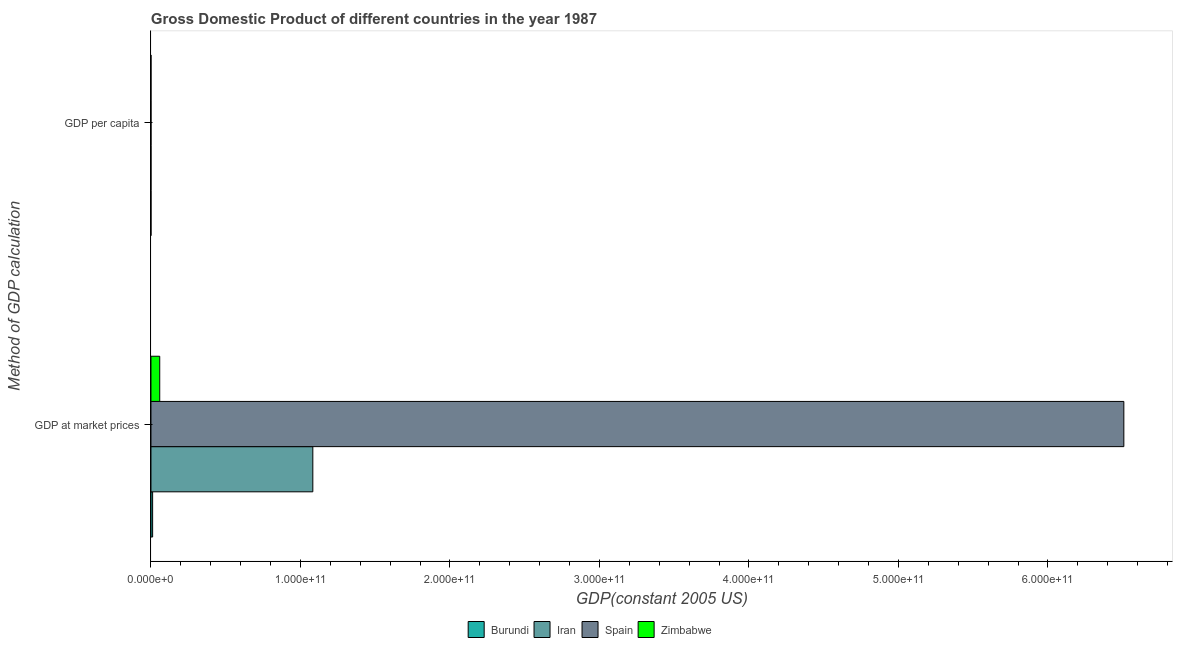How many groups of bars are there?
Offer a terse response. 2. Are the number of bars on each tick of the Y-axis equal?
Your answer should be compact. Yes. What is the label of the 1st group of bars from the top?
Your answer should be very brief. GDP per capita. What is the gdp per capita in Iran?
Your answer should be very brief. 2116.74. Across all countries, what is the maximum gdp per capita?
Your response must be concise. 1.68e+04. Across all countries, what is the minimum gdp at market prices?
Provide a short and direct response. 1.11e+09. In which country was the gdp per capita maximum?
Your response must be concise. Spain. In which country was the gdp per capita minimum?
Your answer should be very brief. Burundi. What is the total gdp at market prices in the graph?
Ensure brevity in your answer.  7.66e+11. What is the difference between the gdp at market prices in Iran and that in Burundi?
Offer a terse response. 1.07e+11. What is the difference between the gdp per capita in Spain and the gdp at market prices in Zimbabwe?
Make the answer very short. -5.86e+09. What is the average gdp at market prices per country?
Ensure brevity in your answer.  1.92e+11. What is the difference between the gdp per capita and gdp at market prices in Iran?
Offer a terse response. -1.08e+11. In how many countries, is the gdp per capita greater than 200000000000 US$?
Offer a very short reply. 0. What is the ratio of the gdp per capita in Iran to that in Spain?
Make the answer very short. 0.13. What does the 3rd bar from the top in GDP at market prices represents?
Ensure brevity in your answer.  Iran. What does the 3rd bar from the bottom in GDP per capita represents?
Keep it short and to the point. Spain. Are all the bars in the graph horizontal?
Your answer should be very brief. Yes. How many countries are there in the graph?
Make the answer very short. 4. What is the difference between two consecutive major ticks on the X-axis?
Your answer should be very brief. 1.00e+11. Does the graph contain any zero values?
Offer a terse response. No. How many legend labels are there?
Your answer should be very brief. 4. How are the legend labels stacked?
Provide a short and direct response. Horizontal. What is the title of the graph?
Ensure brevity in your answer.  Gross Domestic Product of different countries in the year 1987. Does "Libya" appear as one of the legend labels in the graph?
Your answer should be very brief. No. What is the label or title of the X-axis?
Ensure brevity in your answer.  GDP(constant 2005 US). What is the label or title of the Y-axis?
Ensure brevity in your answer.  Method of GDP calculation. What is the GDP(constant 2005 US) of Burundi in GDP at market prices?
Your answer should be very brief. 1.11e+09. What is the GDP(constant 2005 US) in Iran in GDP at market prices?
Offer a very short reply. 1.08e+11. What is the GDP(constant 2005 US) in Spain in GDP at market prices?
Keep it short and to the point. 6.51e+11. What is the GDP(constant 2005 US) in Zimbabwe in GDP at market prices?
Offer a very short reply. 5.86e+09. What is the GDP(constant 2005 US) of Burundi in GDP per capita?
Make the answer very short. 217.47. What is the GDP(constant 2005 US) in Iran in GDP per capita?
Provide a succinct answer. 2116.74. What is the GDP(constant 2005 US) in Spain in GDP per capita?
Your response must be concise. 1.68e+04. What is the GDP(constant 2005 US) in Zimbabwe in GDP per capita?
Provide a short and direct response. 614.99. Across all Method of GDP calculation, what is the maximum GDP(constant 2005 US) of Burundi?
Your response must be concise. 1.11e+09. Across all Method of GDP calculation, what is the maximum GDP(constant 2005 US) in Iran?
Offer a very short reply. 1.08e+11. Across all Method of GDP calculation, what is the maximum GDP(constant 2005 US) of Spain?
Make the answer very short. 6.51e+11. Across all Method of GDP calculation, what is the maximum GDP(constant 2005 US) of Zimbabwe?
Provide a succinct answer. 5.86e+09. Across all Method of GDP calculation, what is the minimum GDP(constant 2005 US) of Burundi?
Offer a very short reply. 217.47. Across all Method of GDP calculation, what is the minimum GDP(constant 2005 US) in Iran?
Provide a short and direct response. 2116.74. Across all Method of GDP calculation, what is the minimum GDP(constant 2005 US) of Spain?
Provide a short and direct response. 1.68e+04. Across all Method of GDP calculation, what is the minimum GDP(constant 2005 US) of Zimbabwe?
Provide a succinct answer. 614.99. What is the total GDP(constant 2005 US) of Burundi in the graph?
Your answer should be compact. 1.11e+09. What is the total GDP(constant 2005 US) in Iran in the graph?
Your answer should be compact. 1.08e+11. What is the total GDP(constant 2005 US) of Spain in the graph?
Provide a succinct answer. 6.51e+11. What is the total GDP(constant 2005 US) of Zimbabwe in the graph?
Give a very brief answer. 5.86e+09. What is the difference between the GDP(constant 2005 US) in Burundi in GDP at market prices and that in GDP per capita?
Keep it short and to the point. 1.11e+09. What is the difference between the GDP(constant 2005 US) in Iran in GDP at market prices and that in GDP per capita?
Ensure brevity in your answer.  1.08e+11. What is the difference between the GDP(constant 2005 US) of Spain in GDP at market prices and that in GDP per capita?
Your answer should be very brief. 6.51e+11. What is the difference between the GDP(constant 2005 US) of Zimbabwe in GDP at market prices and that in GDP per capita?
Ensure brevity in your answer.  5.86e+09. What is the difference between the GDP(constant 2005 US) of Burundi in GDP at market prices and the GDP(constant 2005 US) of Iran in GDP per capita?
Your response must be concise. 1.11e+09. What is the difference between the GDP(constant 2005 US) of Burundi in GDP at market prices and the GDP(constant 2005 US) of Spain in GDP per capita?
Offer a terse response. 1.11e+09. What is the difference between the GDP(constant 2005 US) in Burundi in GDP at market prices and the GDP(constant 2005 US) in Zimbabwe in GDP per capita?
Your response must be concise. 1.11e+09. What is the difference between the GDP(constant 2005 US) of Iran in GDP at market prices and the GDP(constant 2005 US) of Spain in GDP per capita?
Provide a succinct answer. 1.08e+11. What is the difference between the GDP(constant 2005 US) of Iran in GDP at market prices and the GDP(constant 2005 US) of Zimbabwe in GDP per capita?
Make the answer very short. 1.08e+11. What is the difference between the GDP(constant 2005 US) in Spain in GDP at market prices and the GDP(constant 2005 US) in Zimbabwe in GDP per capita?
Provide a succinct answer. 6.51e+11. What is the average GDP(constant 2005 US) of Burundi per Method of GDP calculation?
Your answer should be very brief. 5.55e+08. What is the average GDP(constant 2005 US) of Iran per Method of GDP calculation?
Your answer should be compact. 5.41e+1. What is the average GDP(constant 2005 US) in Spain per Method of GDP calculation?
Your answer should be compact. 3.25e+11. What is the average GDP(constant 2005 US) of Zimbabwe per Method of GDP calculation?
Offer a terse response. 2.93e+09. What is the difference between the GDP(constant 2005 US) in Burundi and GDP(constant 2005 US) in Iran in GDP at market prices?
Keep it short and to the point. -1.07e+11. What is the difference between the GDP(constant 2005 US) of Burundi and GDP(constant 2005 US) of Spain in GDP at market prices?
Offer a very short reply. -6.50e+11. What is the difference between the GDP(constant 2005 US) of Burundi and GDP(constant 2005 US) of Zimbabwe in GDP at market prices?
Make the answer very short. -4.75e+09. What is the difference between the GDP(constant 2005 US) in Iran and GDP(constant 2005 US) in Spain in GDP at market prices?
Offer a terse response. -5.43e+11. What is the difference between the GDP(constant 2005 US) in Iran and GDP(constant 2005 US) in Zimbabwe in GDP at market prices?
Your response must be concise. 1.02e+11. What is the difference between the GDP(constant 2005 US) of Spain and GDP(constant 2005 US) of Zimbabwe in GDP at market prices?
Make the answer very short. 6.45e+11. What is the difference between the GDP(constant 2005 US) in Burundi and GDP(constant 2005 US) in Iran in GDP per capita?
Provide a succinct answer. -1899.27. What is the difference between the GDP(constant 2005 US) of Burundi and GDP(constant 2005 US) of Spain in GDP per capita?
Ensure brevity in your answer.  -1.66e+04. What is the difference between the GDP(constant 2005 US) of Burundi and GDP(constant 2005 US) of Zimbabwe in GDP per capita?
Provide a short and direct response. -397.52. What is the difference between the GDP(constant 2005 US) in Iran and GDP(constant 2005 US) in Spain in GDP per capita?
Ensure brevity in your answer.  -1.47e+04. What is the difference between the GDP(constant 2005 US) in Iran and GDP(constant 2005 US) in Zimbabwe in GDP per capita?
Your response must be concise. 1501.75. What is the difference between the GDP(constant 2005 US) in Spain and GDP(constant 2005 US) in Zimbabwe in GDP per capita?
Offer a terse response. 1.62e+04. What is the ratio of the GDP(constant 2005 US) of Burundi in GDP at market prices to that in GDP per capita?
Offer a very short reply. 5.11e+06. What is the ratio of the GDP(constant 2005 US) in Iran in GDP at market prices to that in GDP per capita?
Make the answer very short. 5.12e+07. What is the ratio of the GDP(constant 2005 US) of Spain in GDP at market prices to that in GDP per capita?
Offer a terse response. 3.86e+07. What is the ratio of the GDP(constant 2005 US) in Zimbabwe in GDP at market prices to that in GDP per capita?
Provide a succinct answer. 9.54e+06. What is the difference between the highest and the second highest GDP(constant 2005 US) of Burundi?
Give a very brief answer. 1.11e+09. What is the difference between the highest and the second highest GDP(constant 2005 US) of Iran?
Provide a succinct answer. 1.08e+11. What is the difference between the highest and the second highest GDP(constant 2005 US) in Spain?
Keep it short and to the point. 6.51e+11. What is the difference between the highest and the second highest GDP(constant 2005 US) of Zimbabwe?
Make the answer very short. 5.86e+09. What is the difference between the highest and the lowest GDP(constant 2005 US) in Burundi?
Your response must be concise. 1.11e+09. What is the difference between the highest and the lowest GDP(constant 2005 US) in Iran?
Keep it short and to the point. 1.08e+11. What is the difference between the highest and the lowest GDP(constant 2005 US) of Spain?
Your answer should be compact. 6.51e+11. What is the difference between the highest and the lowest GDP(constant 2005 US) in Zimbabwe?
Provide a succinct answer. 5.86e+09. 